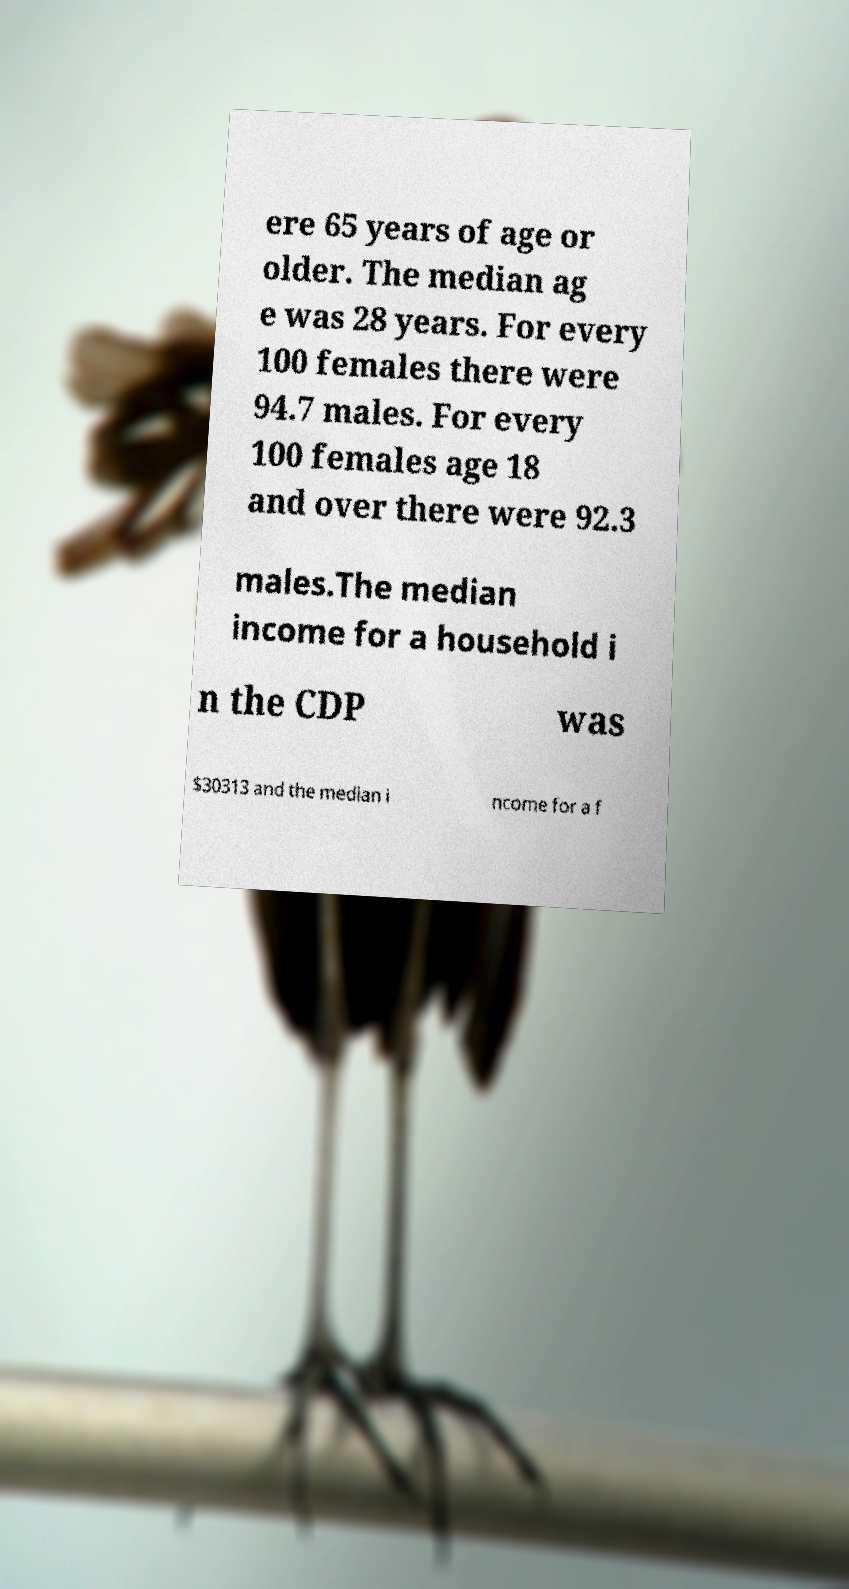Please identify and transcribe the text found in this image. ere 65 years of age or older. The median ag e was 28 years. For every 100 females there were 94.7 males. For every 100 females age 18 and over there were 92.3 males.The median income for a household i n the CDP was $30313 and the median i ncome for a f 